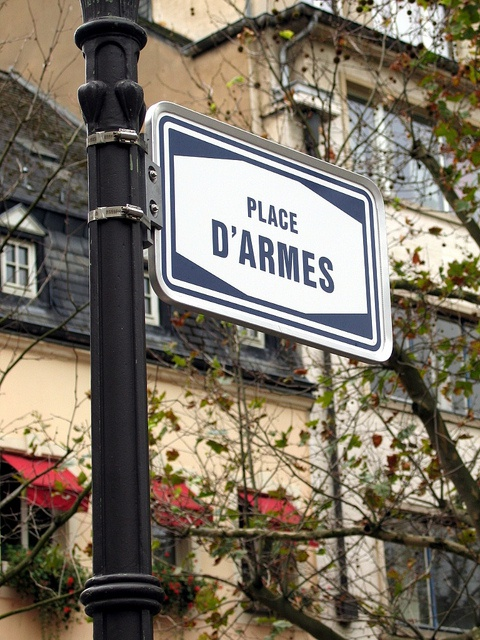Describe the objects in this image and their specific colors. I can see various objects in this image with different colors. 